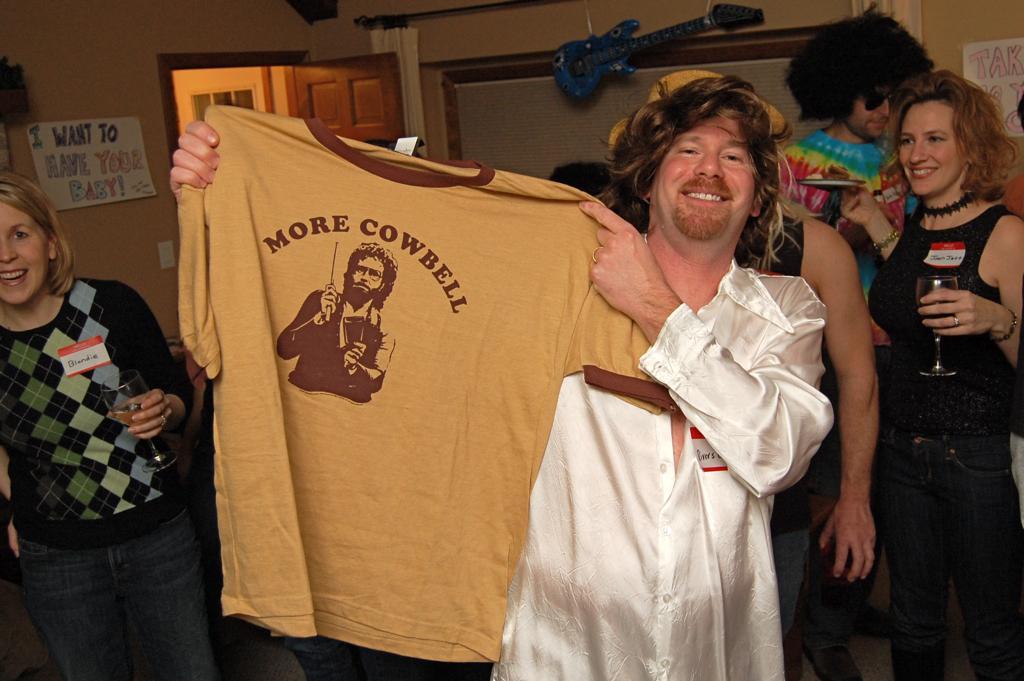In one or two sentences, can you explain what this image depicts? In the image we can see there are many people standing, wearing clothes and they are smiling. We can even see there are few people holding, wine glass in hands. Here we can see the guitar, wall and poster stick to the wall and the door. 